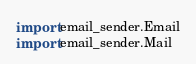<code> <loc_0><loc_0><loc_500><loc_500><_Python_>import email_sender.Email
import email_sender.Mail</code> 